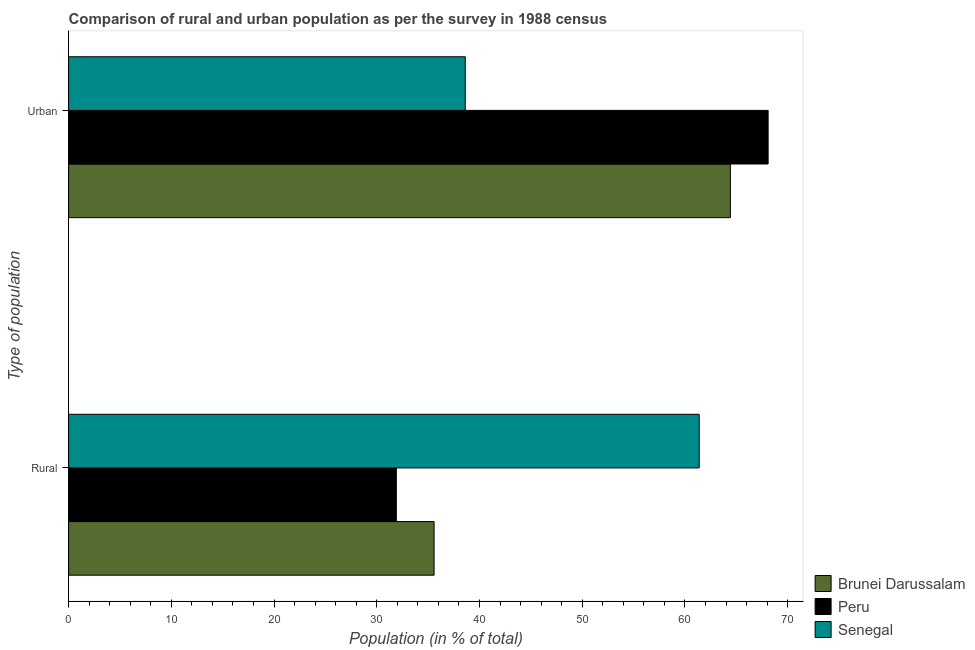How many different coloured bars are there?
Ensure brevity in your answer.  3. How many groups of bars are there?
Your answer should be very brief. 2. Are the number of bars per tick equal to the number of legend labels?
Keep it short and to the point. Yes. How many bars are there on the 2nd tick from the top?
Your answer should be very brief. 3. What is the label of the 2nd group of bars from the top?
Keep it short and to the point. Rural. What is the rural population in Peru?
Keep it short and to the point. 31.91. Across all countries, what is the maximum rural population?
Give a very brief answer. 61.39. Across all countries, what is the minimum urban population?
Ensure brevity in your answer.  38.61. In which country was the rural population maximum?
Provide a succinct answer. Senegal. What is the total urban population in the graph?
Your answer should be very brief. 171.13. What is the difference between the urban population in Peru and that in Brunei Darussalam?
Provide a succinct answer. 3.67. What is the difference between the rural population in Brunei Darussalam and the urban population in Senegal?
Keep it short and to the point. -3.03. What is the average rural population per country?
Provide a succinct answer. 42.96. What is the difference between the rural population and urban population in Peru?
Your answer should be very brief. -36.19. What is the ratio of the urban population in Peru to that in Senegal?
Keep it short and to the point. 1.76. What does the 3rd bar from the top in Urban represents?
Provide a succinct answer. Brunei Darussalam. What does the 3rd bar from the bottom in Rural represents?
Your response must be concise. Senegal. How many bars are there?
Offer a very short reply. 6. What is the difference between two consecutive major ticks on the X-axis?
Make the answer very short. 10. Are the values on the major ticks of X-axis written in scientific E-notation?
Your answer should be compact. No. Does the graph contain any zero values?
Provide a succinct answer. No. What is the title of the graph?
Keep it short and to the point. Comparison of rural and urban population as per the survey in 1988 census. What is the label or title of the X-axis?
Your answer should be very brief. Population (in % of total). What is the label or title of the Y-axis?
Ensure brevity in your answer.  Type of population. What is the Population (in % of total) in Brunei Darussalam in Rural?
Provide a short and direct response. 35.58. What is the Population (in % of total) of Peru in Rural?
Offer a terse response. 31.91. What is the Population (in % of total) of Senegal in Rural?
Give a very brief answer. 61.39. What is the Population (in % of total) of Brunei Darussalam in Urban?
Provide a short and direct response. 64.42. What is the Population (in % of total) of Peru in Urban?
Your response must be concise. 68.09. What is the Population (in % of total) of Senegal in Urban?
Provide a succinct answer. 38.61. Across all Type of population, what is the maximum Population (in % of total) of Brunei Darussalam?
Offer a very short reply. 64.42. Across all Type of population, what is the maximum Population (in % of total) in Peru?
Offer a very short reply. 68.09. Across all Type of population, what is the maximum Population (in % of total) of Senegal?
Offer a terse response. 61.39. Across all Type of population, what is the minimum Population (in % of total) in Brunei Darussalam?
Make the answer very short. 35.58. Across all Type of population, what is the minimum Population (in % of total) of Peru?
Offer a terse response. 31.91. Across all Type of population, what is the minimum Population (in % of total) in Senegal?
Provide a succinct answer. 38.61. What is the total Population (in % of total) in Peru in the graph?
Your answer should be compact. 100. What is the difference between the Population (in % of total) of Brunei Darussalam in Rural and that in Urban?
Offer a very short reply. -28.84. What is the difference between the Population (in % of total) in Peru in Rural and that in Urban?
Your answer should be compact. -36.19. What is the difference between the Population (in % of total) in Senegal in Rural and that in Urban?
Give a very brief answer. 22.77. What is the difference between the Population (in % of total) of Brunei Darussalam in Rural and the Population (in % of total) of Peru in Urban?
Your answer should be very brief. -32.52. What is the difference between the Population (in % of total) of Brunei Darussalam in Rural and the Population (in % of total) of Senegal in Urban?
Your response must be concise. -3.04. What is the difference between the Population (in % of total) of Peru in Rural and the Population (in % of total) of Senegal in Urban?
Ensure brevity in your answer.  -6.71. What is the average Population (in % of total) of Senegal per Type of population?
Provide a succinct answer. 50. What is the difference between the Population (in % of total) of Brunei Darussalam and Population (in % of total) of Peru in Rural?
Make the answer very short. 3.67. What is the difference between the Population (in % of total) in Brunei Darussalam and Population (in % of total) in Senegal in Rural?
Keep it short and to the point. -25.81. What is the difference between the Population (in % of total) of Peru and Population (in % of total) of Senegal in Rural?
Keep it short and to the point. -29.48. What is the difference between the Population (in % of total) of Brunei Darussalam and Population (in % of total) of Peru in Urban?
Keep it short and to the point. -3.67. What is the difference between the Population (in % of total) of Brunei Darussalam and Population (in % of total) of Senegal in Urban?
Your answer should be compact. 25.81. What is the difference between the Population (in % of total) in Peru and Population (in % of total) in Senegal in Urban?
Your answer should be very brief. 29.48. What is the ratio of the Population (in % of total) in Brunei Darussalam in Rural to that in Urban?
Offer a very short reply. 0.55. What is the ratio of the Population (in % of total) of Peru in Rural to that in Urban?
Keep it short and to the point. 0.47. What is the ratio of the Population (in % of total) in Senegal in Rural to that in Urban?
Give a very brief answer. 1.59. What is the difference between the highest and the second highest Population (in % of total) in Brunei Darussalam?
Give a very brief answer. 28.84. What is the difference between the highest and the second highest Population (in % of total) in Peru?
Provide a succinct answer. 36.19. What is the difference between the highest and the second highest Population (in % of total) of Senegal?
Keep it short and to the point. 22.77. What is the difference between the highest and the lowest Population (in % of total) in Brunei Darussalam?
Your answer should be compact. 28.84. What is the difference between the highest and the lowest Population (in % of total) in Peru?
Your response must be concise. 36.19. What is the difference between the highest and the lowest Population (in % of total) in Senegal?
Make the answer very short. 22.77. 